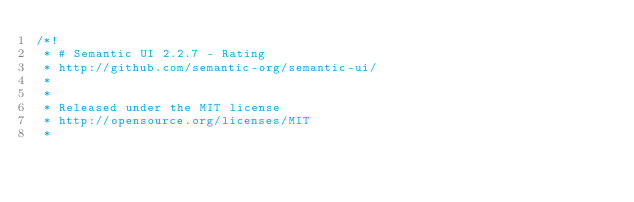<code> <loc_0><loc_0><loc_500><loc_500><_CSS_>/*!
 * # Semantic UI 2.2.7 - Rating
 * http://github.com/semantic-org/semantic-ui/
 *
 *
 * Released under the MIT license
 * http://opensource.org/licenses/MIT
 *</code> 